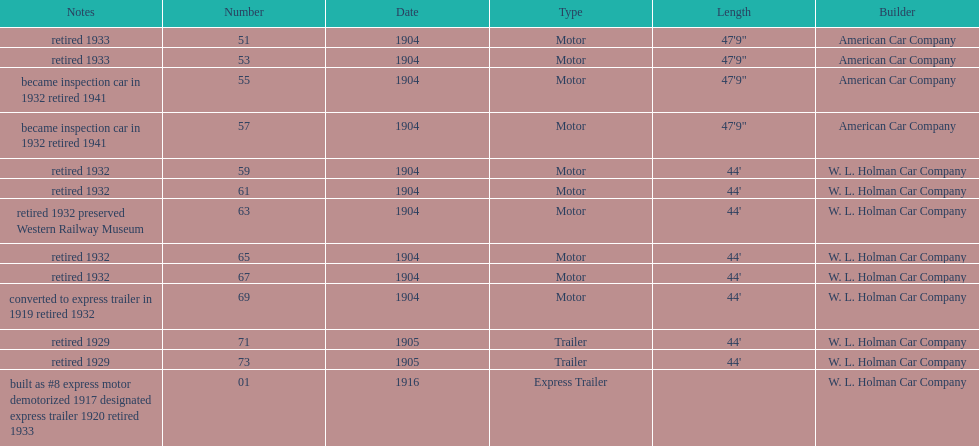How long did it take number 71 to retire? 24. 